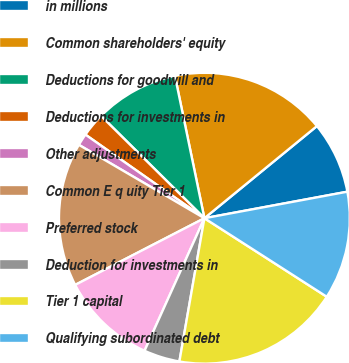Convert chart to OTSL. <chart><loc_0><loc_0><loc_500><loc_500><pie_chart><fcel>in millions<fcel>Common shareholders' equity<fcel>Deductions for goodwill and<fcel>Deductions for investments in<fcel>Other adjustments<fcel>Common E q uity Tier 1<fcel>Preferred stock<fcel>Deduction for investments in<fcel>Tier 1 capital<fcel>Qualifying subordinated debt<nl><fcel>8.0%<fcel>17.33%<fcel>9.33%<fcel>2.67%<fcel>1.33%<fcel>16.0%<fcel>10.67%<fcel>4.0%<fcel>18.67%<fcel>12.0%<nl></chart> 